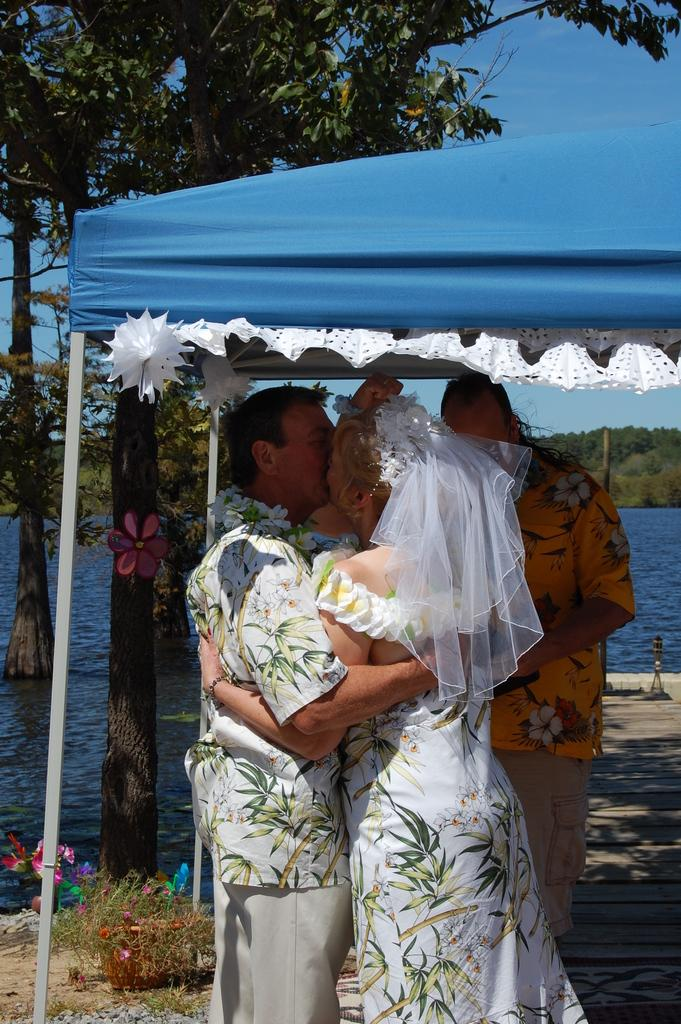What is happening between the two people in the image? The couple is kissing in the image. Where are the couple and the other man located? They are under a tent in the image. What can be seen in the background of the image? There is a lake and trees in the image. What type of vest is the pickle wearing in the image? There is no pickle present in the image, and therefore no vest can be observed. 